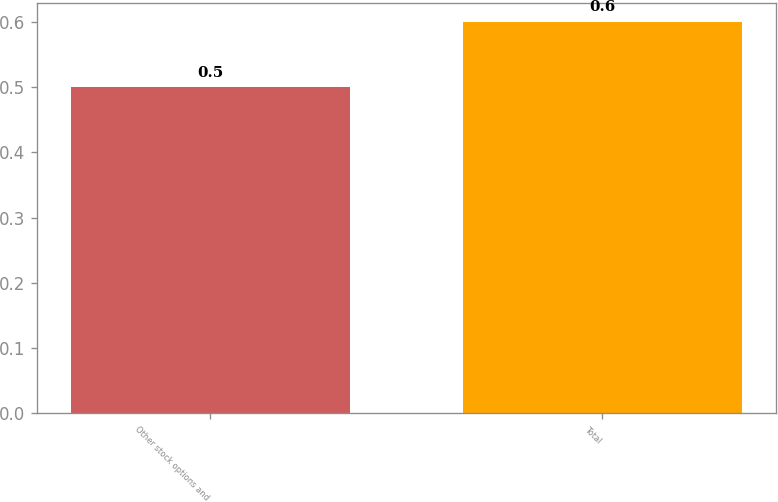<chart> <loc_0><loc_0><loc_500><loc_500><bar_chart><fcel>Other stock options and<fcel>Total<nl><fcel>0.5<fcel>0.6<nl></chart> 